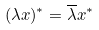Convert formula to latex. <formula><loc_0><loc_0><loc_500><loc_500>( \lambda x ) ^ { * } = \overline { \lambda } x ^ { * }</formula> 